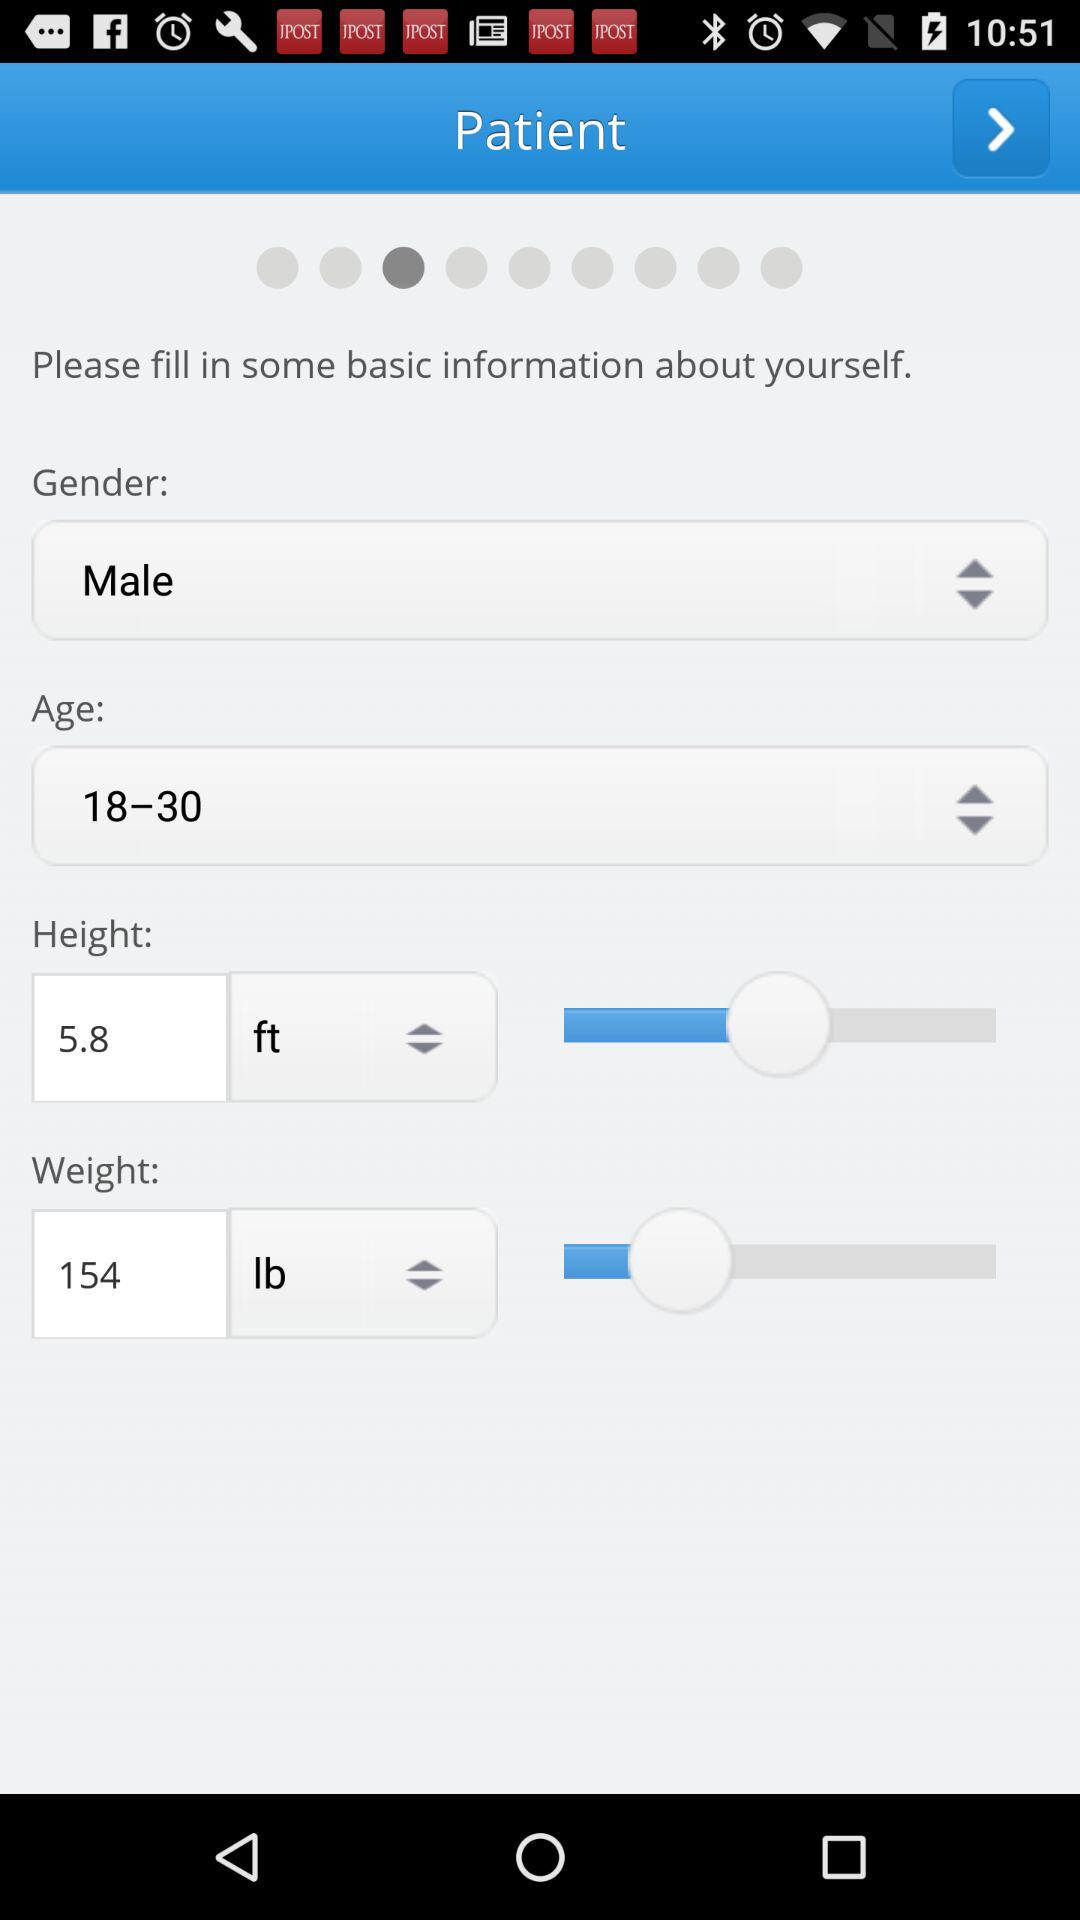What is the weight? The weight is 154 lbs. 